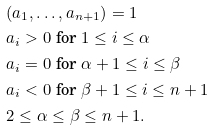<formula> <loc_0><loc_0><loc_500><loc_500>& ( a _ { 1 } , \dots , a _ { n + 1 } ) = 1 \\ & a _ { i } > 0 \text { for } 1 \leq i \leq \alpha \\ & a _ { i } = 0 \text { for } \alpha + 1 \leq i \leq \beta \\ & a _ { i } < 0 \text { for } \beta + 1 \leq i \leq n + 1 \\ & 2 \leq \alpha \leq \beta \leq n + 1 .</formula> 